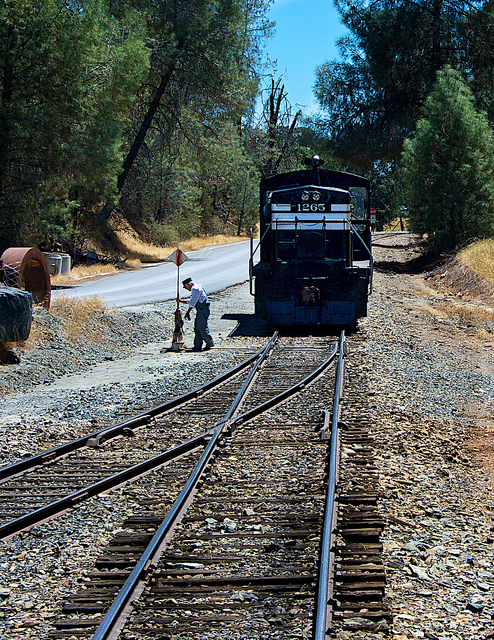Can you describe the environment surrounding the train? The locomotive is situated on railroad tracks that appear to be surrounded by a dry, perhaps rural setting with sparse vegetation, possibly indicative of a region with a hot or arid climate. 